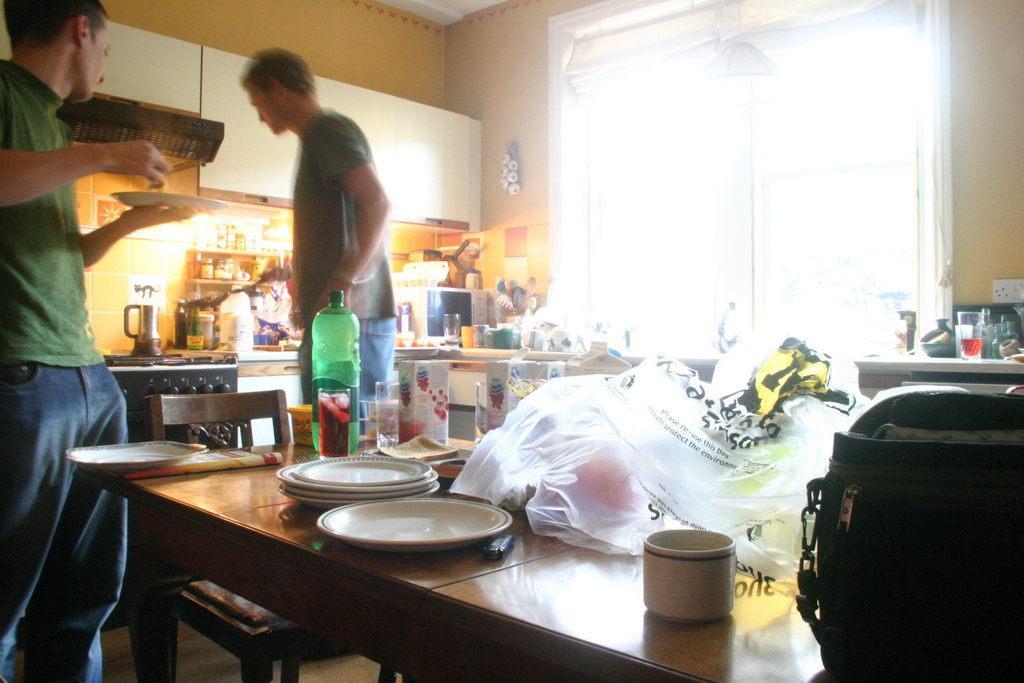Please provide a concise description of this image. This is a wooden table where plates, a bottle, a cup and a glass are kept on it. There is a person standing on the left side and he is holding a plate in his hand and we can see another person on the right side. 